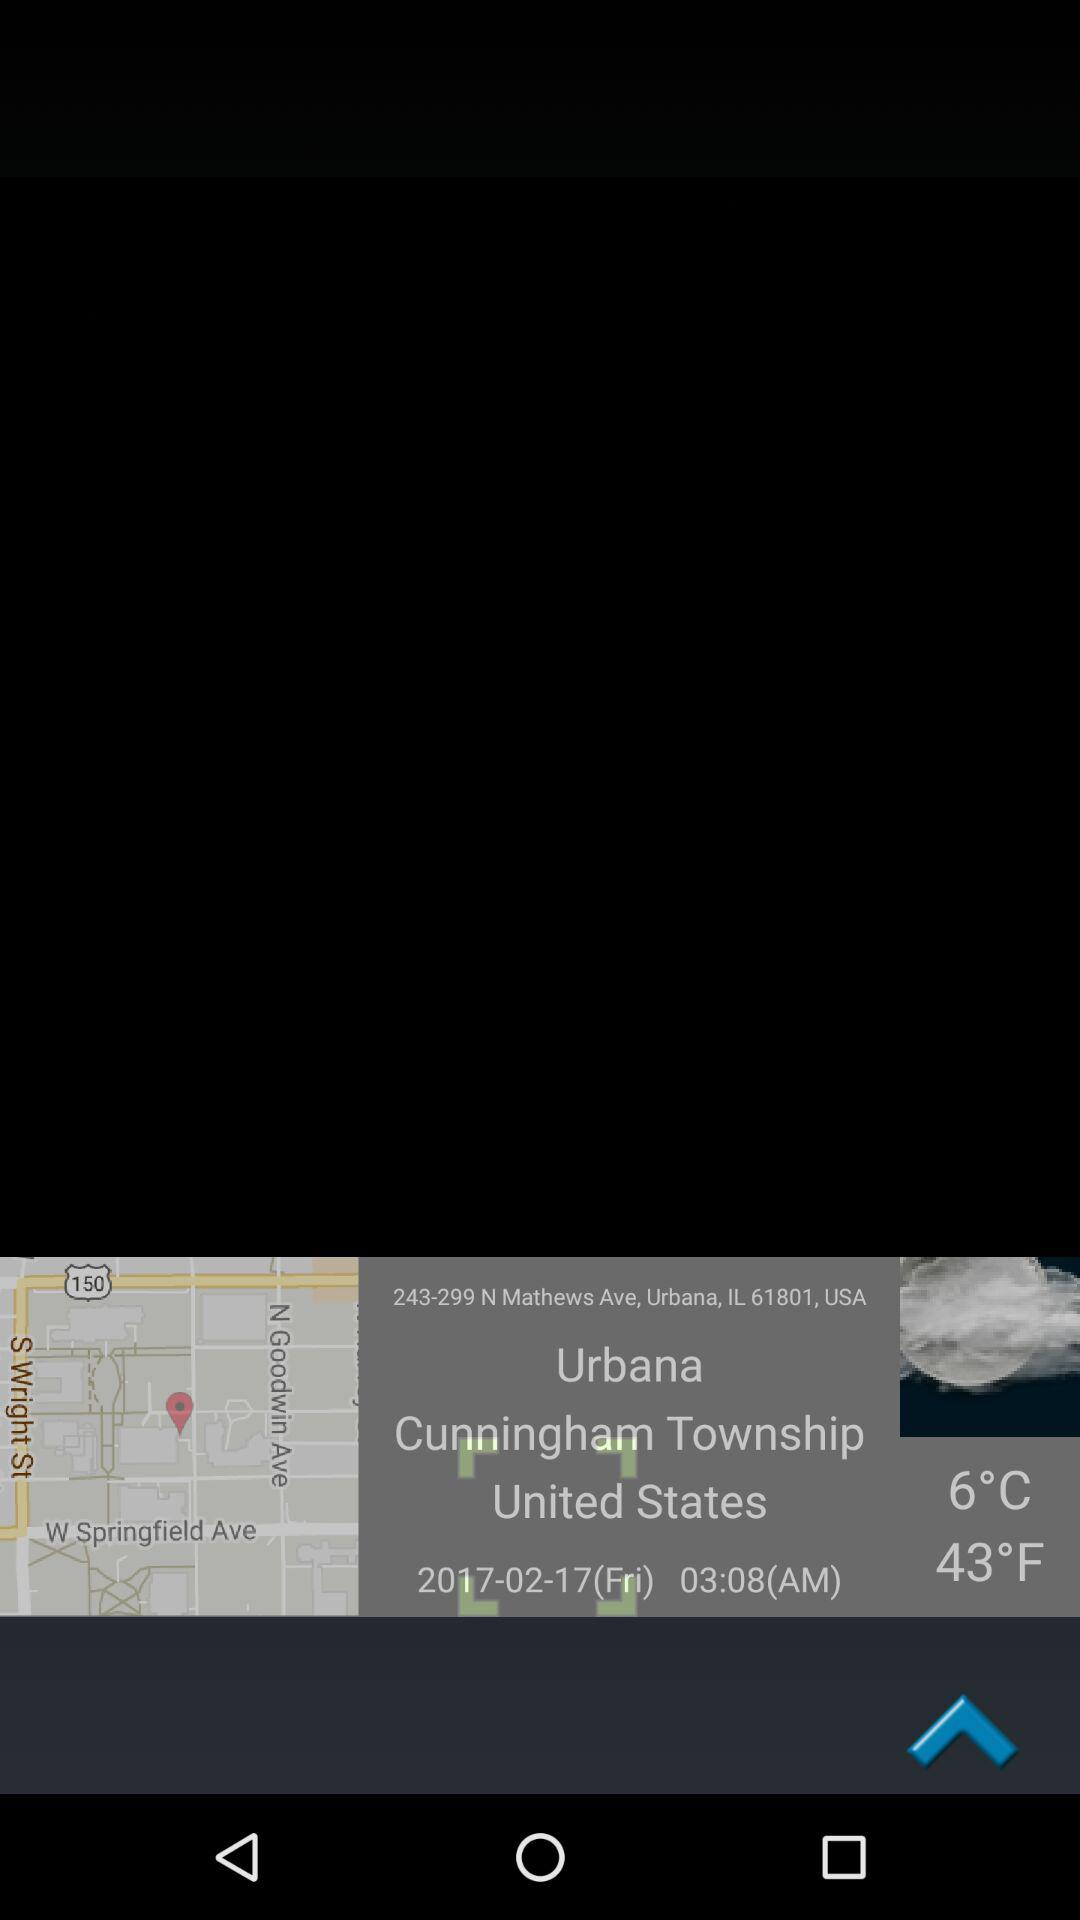What is the given time? The given time is 03:08 AM. 